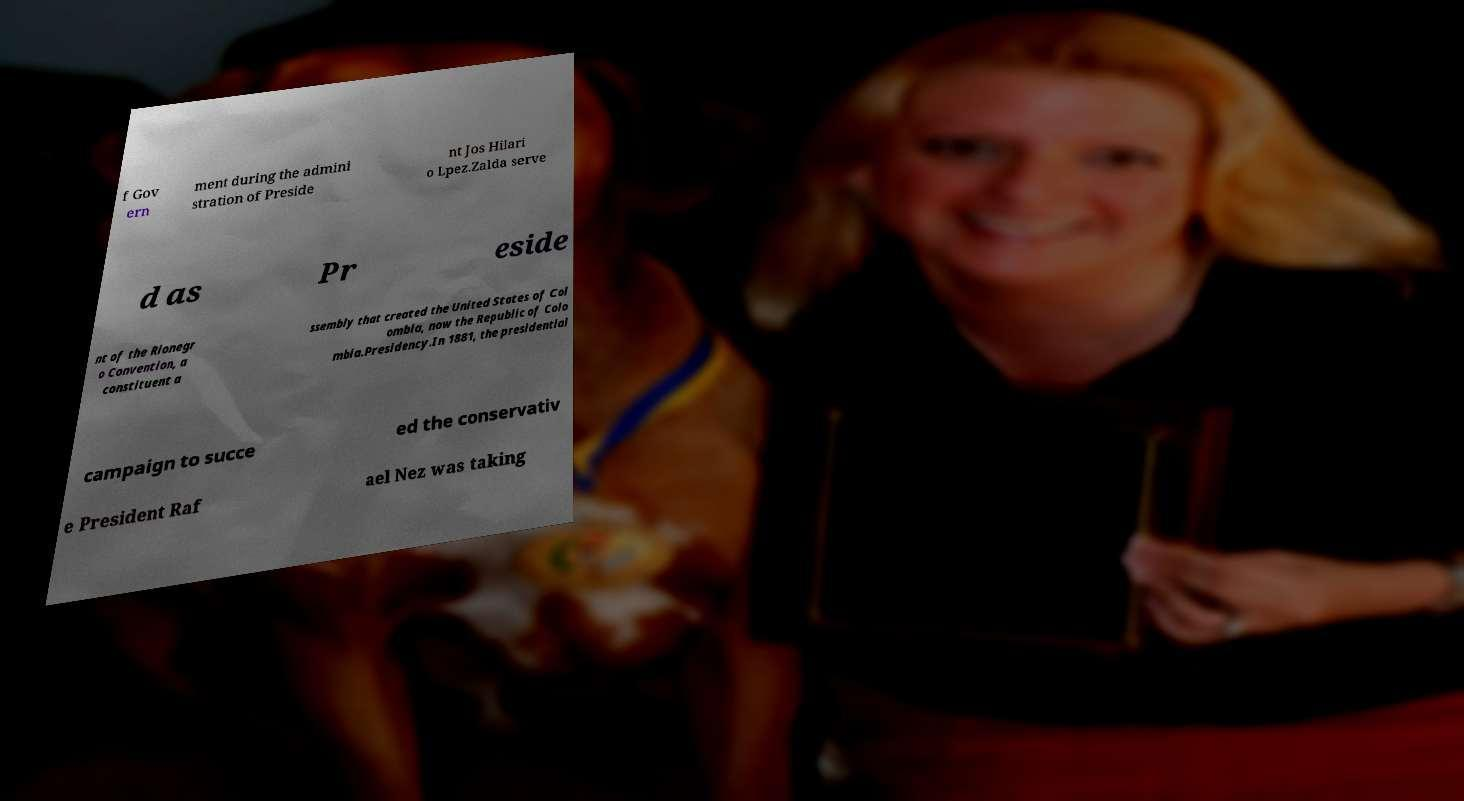There's text embedded in this image that I need extracted. Can you transcribe it verbatim? f Gov ern ment during the admini stration of Preside nt Jos Hilari o Lpez.Zalda serve d as Pr eside nt of the Rionegr o Convention, a constituent a ssembly that created the United States of Col ombia, now the Republic of Colo mbia.Presidency.In 1881, the presidential campaign to succe ed the conservativ e President Raf ael Nez was taking 